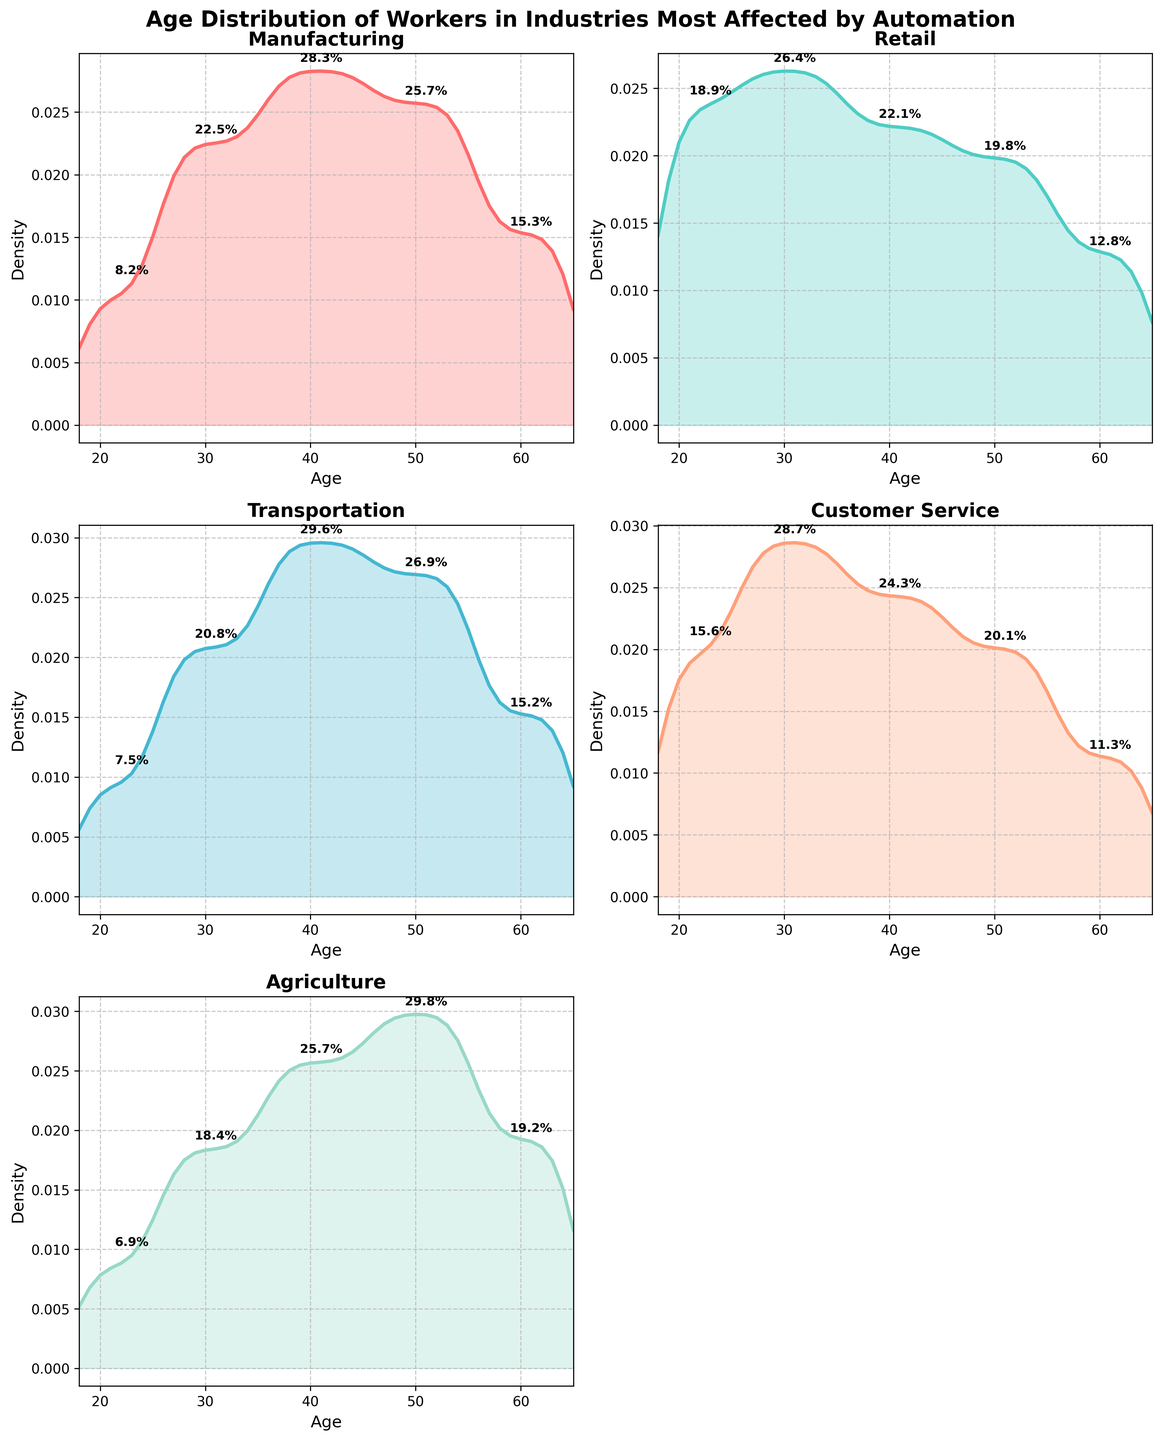What is the title of the figure? The title of the figure is located at the top center of the plot. It summarizes the main topic of the figure.
Answer: Age Distribution of Workers in Industries Most Affected by Automation What is the industry with the highest density for the age group 36-45? To find this, look at the density curve peaks for the 36-45 age range across each subplot. The highest peak in this age group indicates the highest density.
Answer: Transportation Which industry has the youngest workforce distribution? Identify the subplots by examining where the density curves for younger age groups are the highest.
Answer: Retail How does the age density in the "Manufacturing" industry compare to the "Agriculture" industry for workers aged 46-55? Compare the density curves in the two respective plots for the age group 46-55. Look for which industry has a higher peak in this range.
Answer: Agriculture has a higher density Which industry has the least percentage of workers in the 56-65 age range? Identify the subplot with the smallest peak or density value within the 56-65 age group.
Answer: Customer Service What is the general age distribution shape for workers in the "Customer Service" industry? Observe the density plot shape to describe the age distribution trend, noting where peaks and troughs occur.
Answer: Skewed towards younger ages, peaking around 26-35 Which two industries show the most similar age distribution patterns? Compare the density plots visually to see which curves overlap most closely or have similar shapes and peaks across all age groups.
Answer: Manufacturing and Transportation Is the age group 26-35 significant in any of these industries' distributions? Examine the peaks of the density curves for the age group 26-35 across all subplots. Determine if any industry has a notably high peak in this range.
Answer: Retail and Customer Service What is the median age group of workers in the "Agriculture" industry? Assess the plot for Agriculture by identifying the age group where the cumulative distribution reaches about 50%. This is indicated by the area under the density curve up to the median.
Answer: 46-55 Which industry has the most evenly spread age distribution? Find the subplot where the density curve has the least pronounced peaks and is more evenly spread across all age ranges.
Answer: Manufacturing 